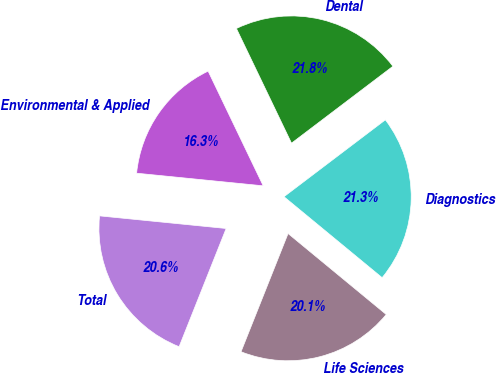<chart> <loc_0><loc_0><loc_500><loc_500><pie_chart><fcel>Life Sciences<fcel>Diagnostics<fcel>Dental<fcel>Environmental & Applied<fcel>Total<nl><fcel>20.05%<fcel>21.3%<fcel>21.8%<fcel>16.29%<fcel>20.55%<nl></chart> 